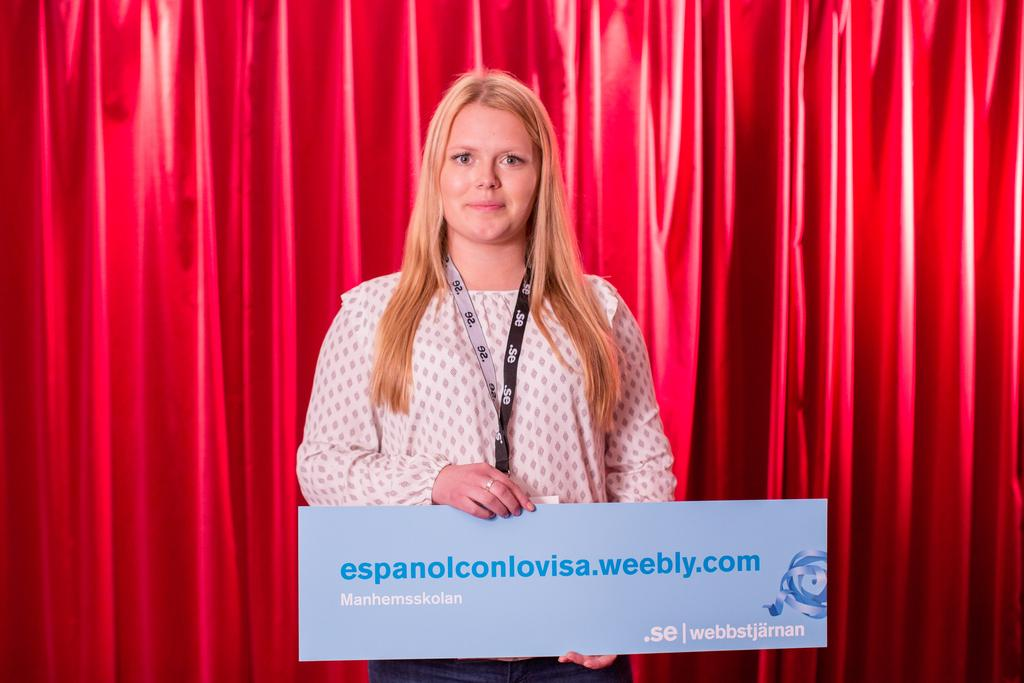What is the person in the image doing? The person is standing in the image and holding a board. What can be seen in the background of the image? There are curtains in the background of the image. What type of sheet is draped over the church in the image? There is no church or sheet present in the image; it features a person holding a board with curtains in the background. 